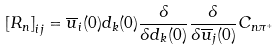Convert formula to latex. <formula><loc_0><loc_0><loc_500><loc_500>\left [ R _ { n } \right ] _ { i j } = \overline { u } _ { i } ( 0 ) d _ { k } ( 0 ) \frac { \delta } { \delta d _ { k } ( 0 ) } \frac { \delta } { \delta \overline { u } _ { j } ( 0 ) } C _ { n \pi ^ { + } }</formula> 